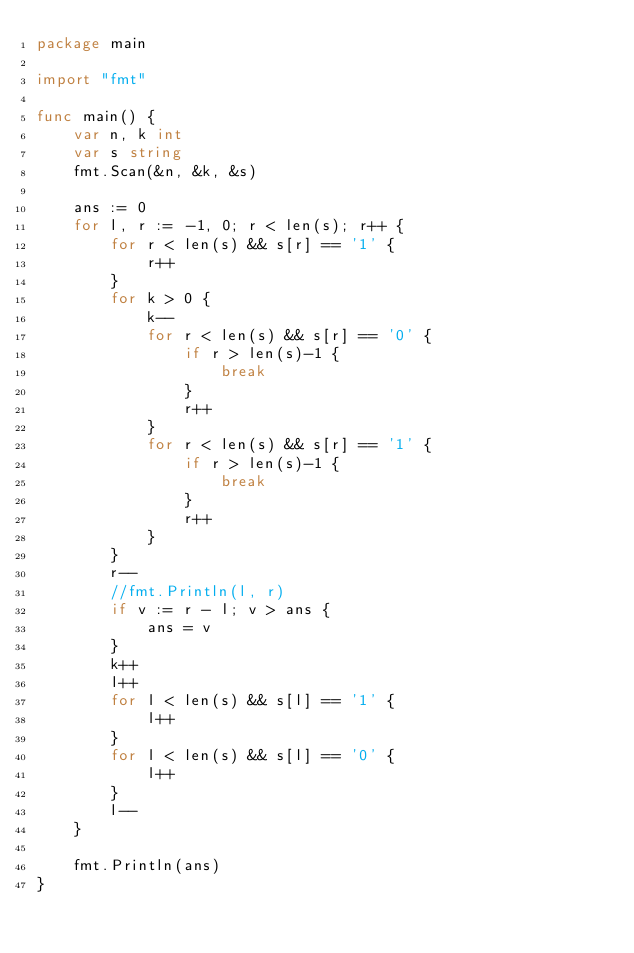<code> <loc_0><loc_0><loc_500><loc_500><_Go_>package main

import "fmt"

func main() {
	var n, k int
	var s string
	fmt.Scan(&n, &k, &s)

	ans := 0
	for l, r := -1, 0; r < len(s); r++ {
		for r < len(s) && s[r] == '1' {
			r++
		}
		for k > 0 {
			k--
			for r < len(s) && s[r] == '0' {
				if r > len(s)-1 {
					break
				}
				r++
			}
			for r < len(s) && s[r] == '1' {
				if r > len(s)-1 {
					break
				}
				r++
			}
		}
		r--
		//fmt.Println(l, r)
		if v := r - l; v > ans {
			ans = v
		}
		k++
		l++
		for l < len(s) && s[l] == '1' {
			l++
		}
		for l < len(s) && s[l] == '0' {
			l++
		}
		l--
	}

	fmt.Println(ans)
}
</code> 